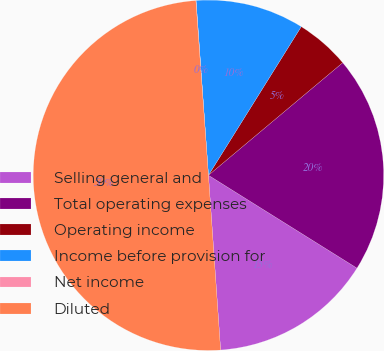Convert chart. <chart><loc_0><loc_0><loc_500><loc_500><pie_chart><fcel>Selling general and<fcel>Total operating expenses<fcel>Operating income<fcel>Income before provision for<fcel>Net income<fcel>Diluted<nl><fcel>15.0%<fcel>20.0%<fcel>5.01%<fcel>10.01%<fcel>0.02%<fcel>49.96%<nl></chart> 